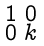<formula> <loc_0><loc_0><loc_500><loc_500>\begin{smallmatrix} 1 & 0 \\ 0 & k \\ \end{smallmatrix}</formula> 